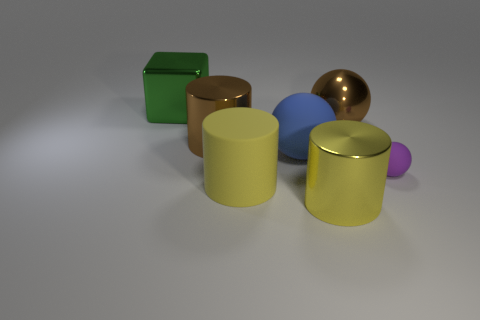Subtract all brown spheres. How many spheres are left? 2 Subtract all brown cylinders. How many cylinders are left? 2 Add 2 large brown blocks. How many objects exist? 9 Subtract all balls. How many objects are left? 4 Subtract 1 spheres. How many spheres are left? 2 Subtract all yellow cylinders. Subtract all big yellow rubber cylinders. How many objects are left? 4 Add 4 large matte cylinders. How many large matte cylinders are left? 5 Add 2 tiny red metallic blocks. How many tiny red metallic blocks exist? 2 Subtract 0 red cylinders. How many objects are left? 7 Subtract all brown cylinders. Subtract all gray blocks. How many cylinders are left? 2 